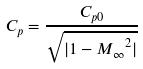<formula> <loc_0><loc_0><loc_500><loc_500>C _ { p } = \frac { C _ { p 0 } } { \sqrt { | 1 - { M _ { \infty } } ^ { 2 } | } }</formula> 